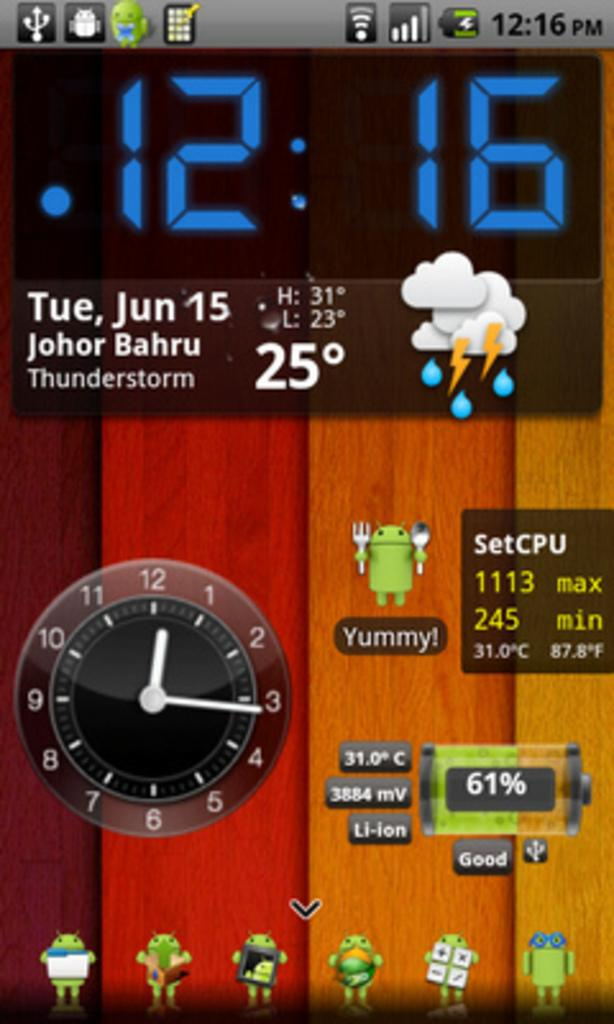<image>
Provide a brief description of the given image. A phone screen shows the time as 12:16 on June 15th. 